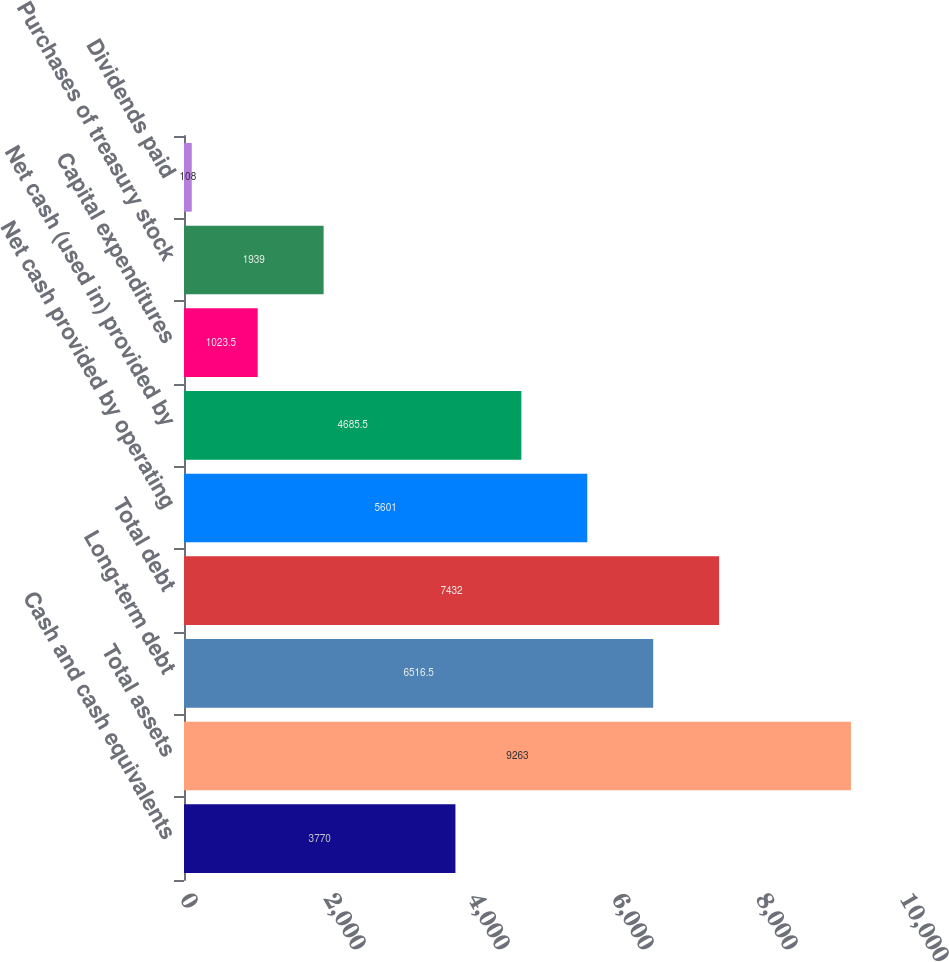Convert chart to OTSL. <chart><loc_0><loc_0><loc_500><loc_500><bar_chart><fcel>Cash and cash equivalents<fcel>Total assets<fcel>Long-term debt<fcel>Total debt<fcel>Net cash provided by operating<fcel>Net cash (used in) provided by<fcel>Capital expenditures<fcel>Purchases of treasury stock<fcel>Dividends paid<nl><fcel>3770<fcel>9263<fcel>6516.5<fcel>7432<fcel>5601<fcel>4685.5<fcel>1023.5<fcel>1939<fcel>108<nl></chart> 